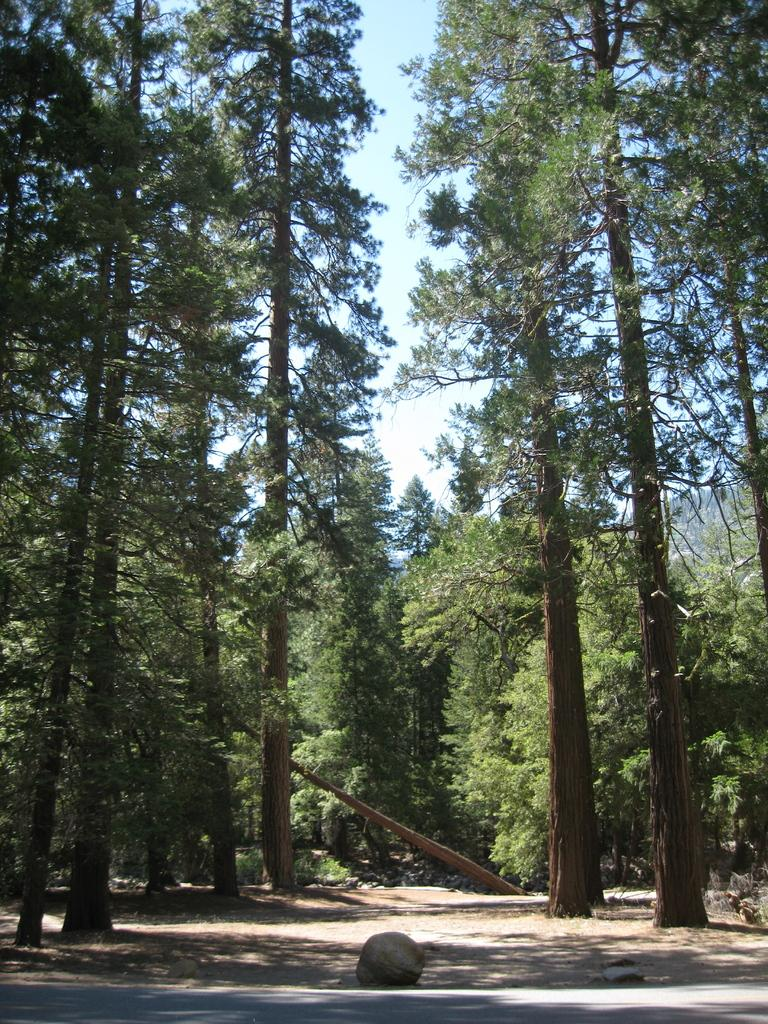What is located at the bottom of the image? There is a road at the bottom of the image. What object can be seen near the road? There is a stone near the road. What type of vegetation is visible in the background of the image? There are trees in the background of the image. What part of the natural environment is visible in the background of the image? The sky is visible in the background of the image. How does the crook interact with the stone in the image? There is no crook present in the image, so it is not possible to answer that question. 